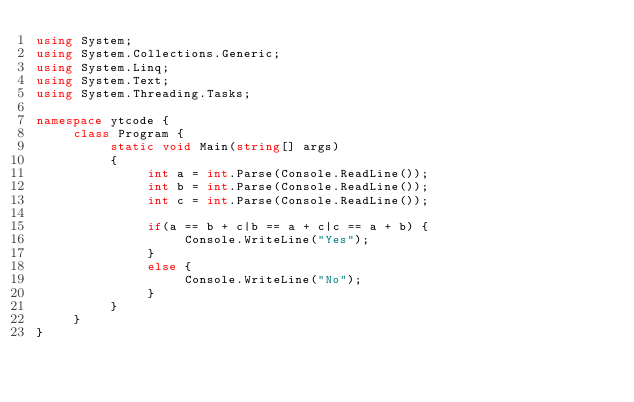Convert code to text. <code><loc_0><loc_0><loc_500><loc_500><_C#_>using System;
using System.Collections.Generic;
using System.Linq;
using System.Text;
using System.Threading.Tasks;

namespace ytcode {
     class Program {
          static void Main(string[] args)
          {
               int a = int.Parse(Console.ReadLine());
               int b = int.Parse(Console.ReadLine());
               int c = int.Parse(Console.ReadLine());

               if(a == b + c|b == a + c|c == a + b) {
                    Console.WriteLine("Yes");
               }
               else {
                    Console.WriteLine("No");
               }
          }
     }
}
</code> 